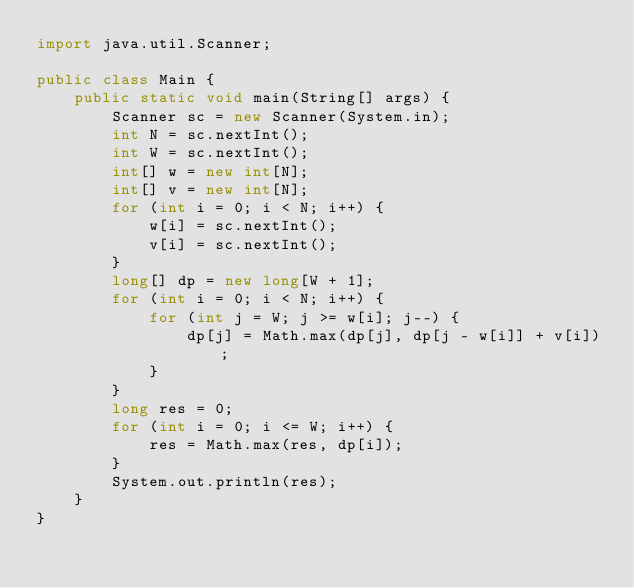Convert code to text. <code><loc_0><loc_0><loc_500><loc_500><_Java_>import java.util.Scanner;

public class Main {
    public static void main(String[] args) {
        Scanner sc = new Scanner(System.in);
        int N = sc.nextInt();
        int W = sc.nextInt();
        int[] w = new int[N];
        int[] v = new int[N];
        for (int i = 0; i < N; i++) {
            w[i] = sc.nextInt();
            v[i] = sc.nextInt();
        }
        long[] dp = new long[W + 1];
        for (int i = 0; i < N; i++) {
            for (int j = W; j >= w[i]; j--) {
                dp[j] = Math.max(dp[j], dp[j - w[i]] + v[i]);
            }
        }
        long res = 0;
        for (int i = 0; i <= W; i++) {
            res = Math.max(res, dp[i]);
        }
        System.out.println(res);
    }
}</code> 